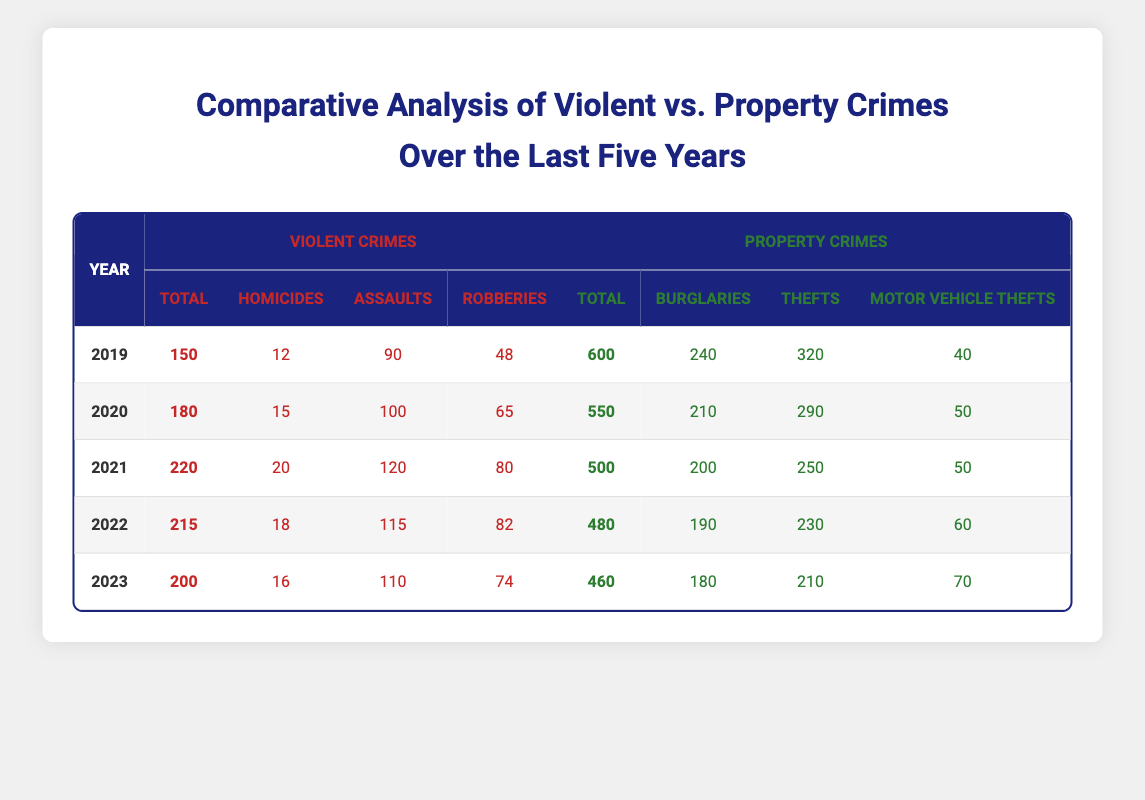What was the total number of violent crimes in 2021? The table shows that in 2021, the total number of violent crimes is listed as 220.
Answer: 220 In which year did property crimes total the highest? By looking at the total property crimes for each year in the table, 2019 has the highest number at 600.
Answer: 2019 What is the difference in total violent crimes between 2020 and 2022? The total violent crimes in 2020 is 180, and in 2022 is 215. The difference is calculated as 215 - 180 = 35.
Answer: 35 True or False: The number of burglaries in 2023 is lower than in 2021. The number of burglaries in 2023 is 180, while in 2021 it is 200. Since 180 is less than 200, the statement is true.
Answer: True What was the average number of homicides over the five years? The total number of homicides from 2019 (12), 2020 (15), 2021 (20), 2022 (18), and 2023 (16) is 81. Dividing this by 5 gives an average of 81 / 5 = 16.2.
Answer: 16.2 In which year did assaults reach their peak and what was the total? The maximum number of assaults is found to be in 2021 with a total of 120.
Answer: 2021, 120 What is the trend for total property crimes from 2019 to 2023? The property crimes decline from 600 in 2019 to 460 in 2023. By examining year-over-year, there’s a steady decrease indicating a negative trend.
Answer: Decreasing How many more robberies were committed in 2020 compared to 2023? The robberies in 2020 total 65, while in 2023 they total 74. The increase is 65 - 74 = -9, indicating fewer robberies in 2023.
Answer: -9 Which year had the fewest motor vehicle thefts, and how many were there? The year with the fewest motor vehicle thefts is 2021 with a total of 50.
Answer: 2021, 50 What was the total number of violent crimes over the five years? Adding the totals of each year (150 + 180 + 220 + 215 + 200) results in 1065.
Answer: 1065 Summarize the total property crime numbers over these years (2019-2023). Total property crimes can be computed by summing each year's total (600 + 550 + 500 + 480 + 460), which equals 2590.
Answer: 2590 